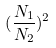Convert formula to latex. <formula><loc_0><loc_0><loc_500><loc_500>( \frac { N _ { 1 } } { N _ { 2 } } ) ^ { 2 }</formula> 